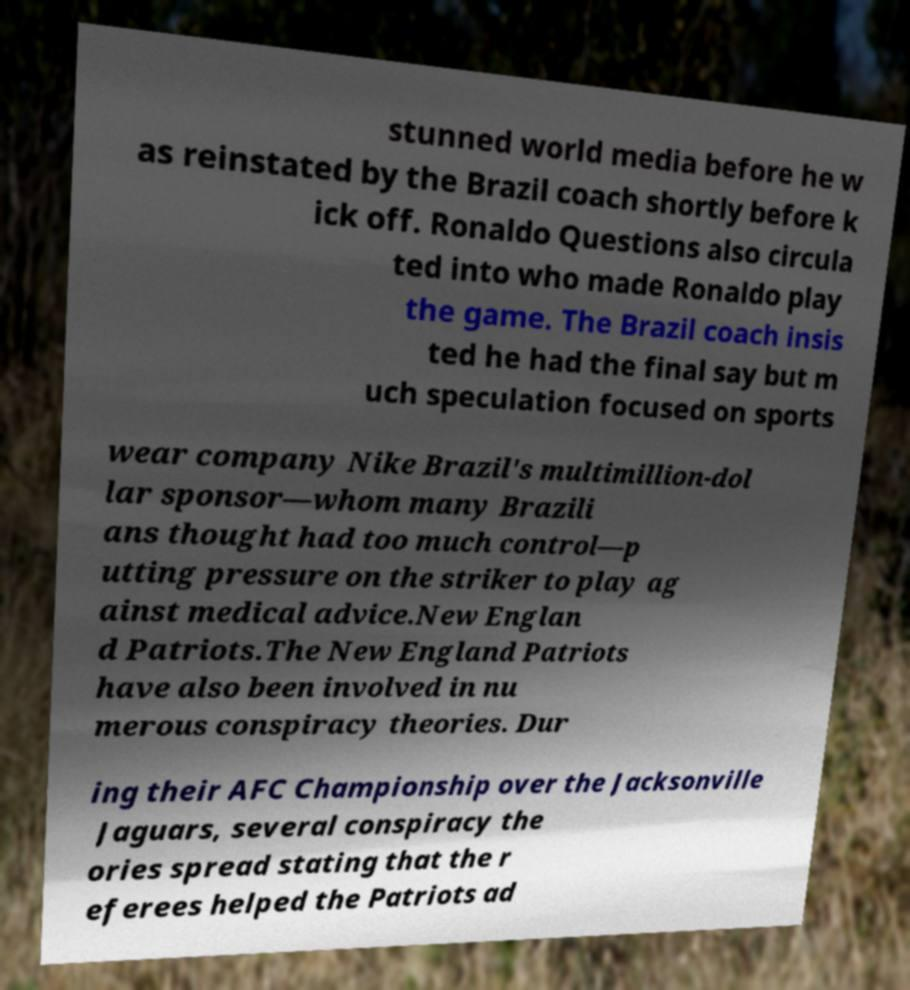I need the written content from this picture converted into text. Can you do that? stunned world media before he w as reinstated by the Brazil coach shortly before k ick off. Ronaldo Questions also circula ted into who made Ronaldo play the game. The Brazil coach insis ted he had the final say but m uch speculation focused on sports wear company Nike Brazil's multimillion-dol lar sponsor—whom many Brazili ans thought had too much control—p utting pressure on the striker to play ag ainst medical advice.New Englan d Patriots.The New England Patriots have also been involved in nu merous conspiracy theories. Dur ing their AFC Championship over the Jacksonville Jaguars, several conspiracy the ories spread stating that the r eferees helped the Patriots ad 